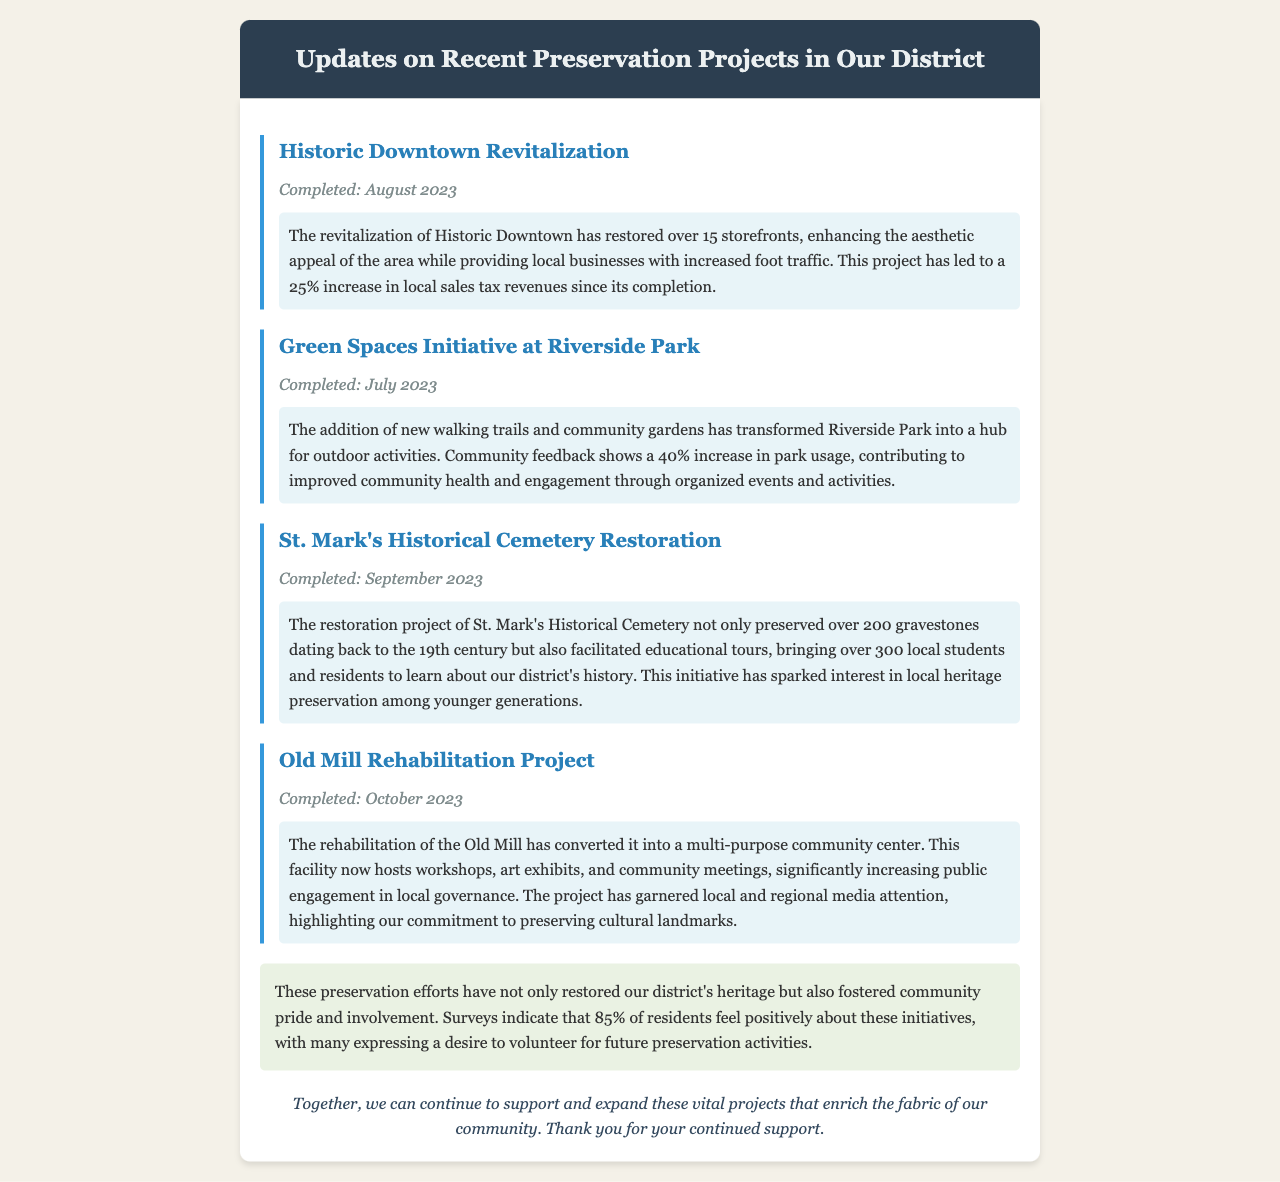What is the title of the first project mentioned? The title of the first project is "Historic Downtown Revitalization."
Answer: Historic Downtown Revitalization When was the Green Spaces Initiative at Riverside Park completed? The document states that the project was completed in July 2023.
Answer: July 2023 How many storefronts were restored in the Historic Downtown Revitalization? The document specifies that over 15 storefronts were restored.
Answer: over 15 What percentage increase in park usage was reported after the Riverside Park project? Community feedback indicates a 40% increase in park usage following the project's completion.
Answer: 40% How many gravestones were preserved in the St. Mark's Historical Cemetery Restoration? The restoration preserved over 200 gravestones.
Answer: over 200 What is the primary purpose of the Old Mill after its rehabilitation? The Old Mill has been converted into a multi-purpose community center.
Answer: multi-purpose community center What did 85% of residents express regarding the preservation initiatives? A survey indicates that 85% of residents feel positively about the preservation initiatives.
Answer: positively What type of community activities does the Old Mill now host? The Old Mill now hosts workshops, art exhibits, and community meetings.
Answer: workshops, art exhibits, and community meetings What impact have the preservation projects had on local businesses according to the document? The revitalization led to a 25% increase in local sales tax revenues.
Answer: 25% increase in local sales tax revenues 